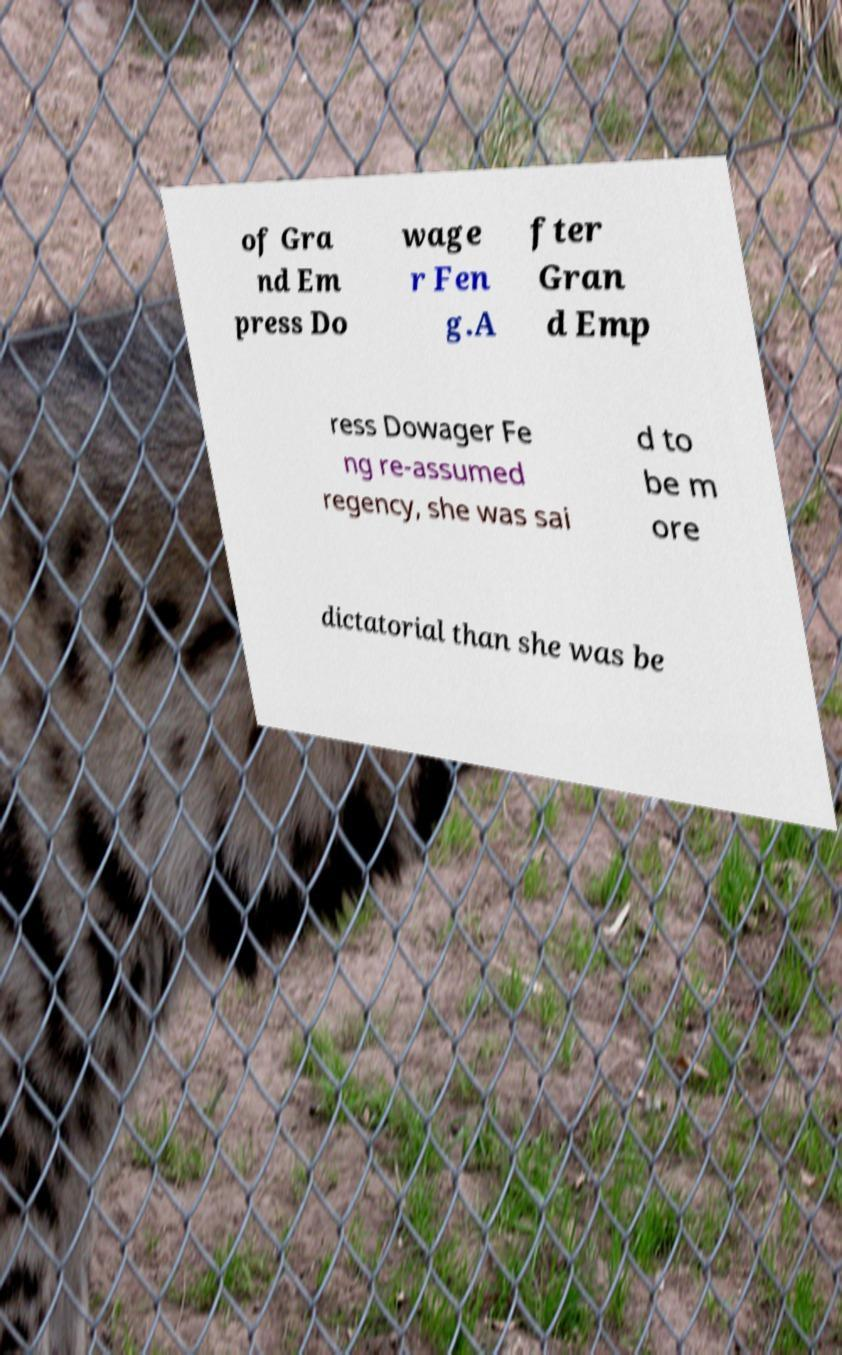I need the written content from this picture converted into text. Can you do that? of Gra nd Em press Do wage r Fen g.A fter Gran d Emp ress Dowager Fe ng re-assumed regency, she was sai d to be m ore dictatorial than she was be 